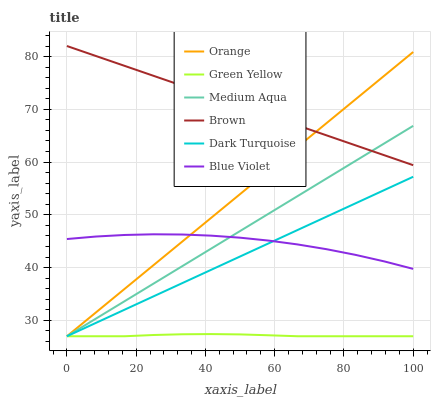Does Green Yellow have the minimum area under the curve?
Answer yes or no. Yes. Does Brown have the maximum area under the curve?
Answer yes or no. Yes. Does Dark Turquoise have the minimum area under the curve?
Answer yes or no. No. Does Dark Turquoise have the maximum area under the curve?
Answer yes or no. No. Is Dark Turquoise the smoothest?
Answer yes or no. Yes. Is Blue Violet the roughest?
Answer yes or no. Yes. Is Orange the smoothest?
Answer yes or no. No. Is Orange the roughest?
Answer yes or no. No. Does Blue Violet have the lowest value?
Answer yes or no. No. Does Brown have the highest value?
Answer yes or no. Yes. Does Dark Turquoise have the highest value?
Answer yes or no. No. Is Blue Violet less than Brown?
Answer yes or no. Yes. Is Brown greater than Blue Violet?
Answer yes or no. Yes. Does Blue Violet intersect Orange?
Answer yes or no. Yes. Is Blue Violet less than Orange?
Answer yes or no. No. Is Blue Violet greater than Orange?
Answer yes or no. No. Does Blue Violet intersect Brown?
Answer yes or no. No. 